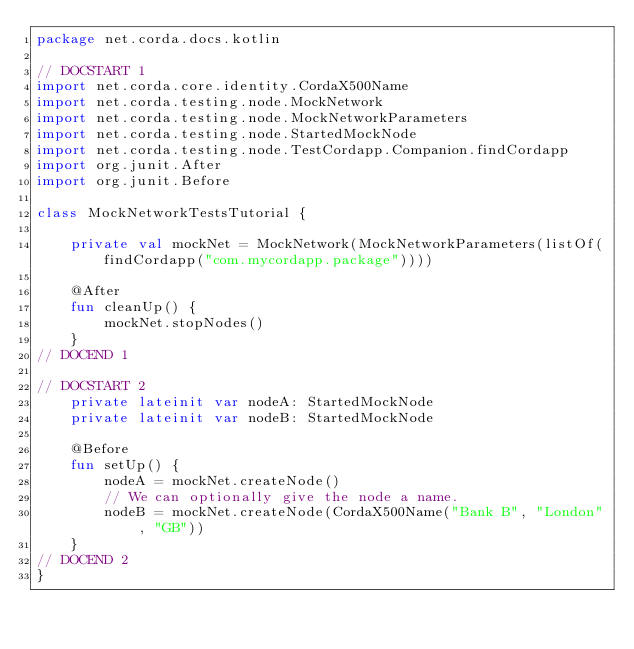Convert code to text. <code><loc_0><loc_0><loc_500><loc_500><_Kotlin_>package net.corda.docs.kotlin

// DOCSTART 1
import net.corda.core.identity.CordaX500Name
import net.corda.testing.node.MockNetwork
import net.corda.testing.node.MockNetworkParameters
import net.corda.testing.node.StartedMockNode
import net.corda.testing.node.TestCordapp.Companion.findCordapp
import org.junit.After
import org.junit.Before

class MockNetworkTestsTutorial {

    private val mockNet = MockNetwork(MockNetworkParameters(listOf(findCordapp("com.mycordapp.package"))))

    @After
    fun cleanUp() {
        mockNet.stopNodes()
    }
// DOCEND 1

// DOCSTART 2
    private lateinit var nodeA: StartedMockNode
    private lateinit var nodeB: StartedMockNode

    @Before
    fun setUp() {
        nodeA = mockNet.createNode()
        // We can optionally give the node a name.
        nodeB = mockNet.createNode(CordaX500Name("Bank B", "London", "GB"))
    }
// DOCEND 2
}
</code> 